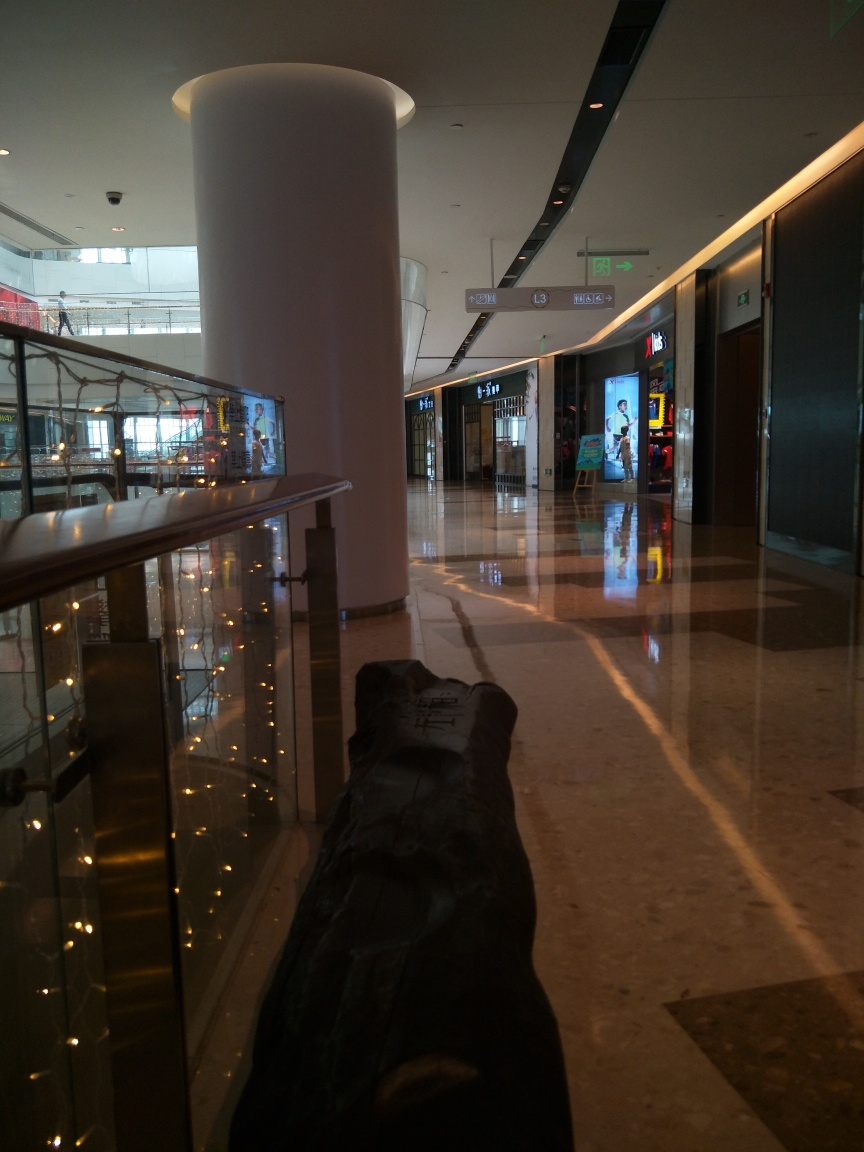What time of day does it seem to be here? It appears to be daytime, judging by the natural light entering through what might be an exterior-facing entrance seen in the distance. 